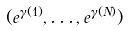<formula> <loc_0><loc_0><loc_500><loc_500>( e ^ { \gamma ( 1 ) } , \dots , e ^ { \gamma ( N ) } )</formula> 